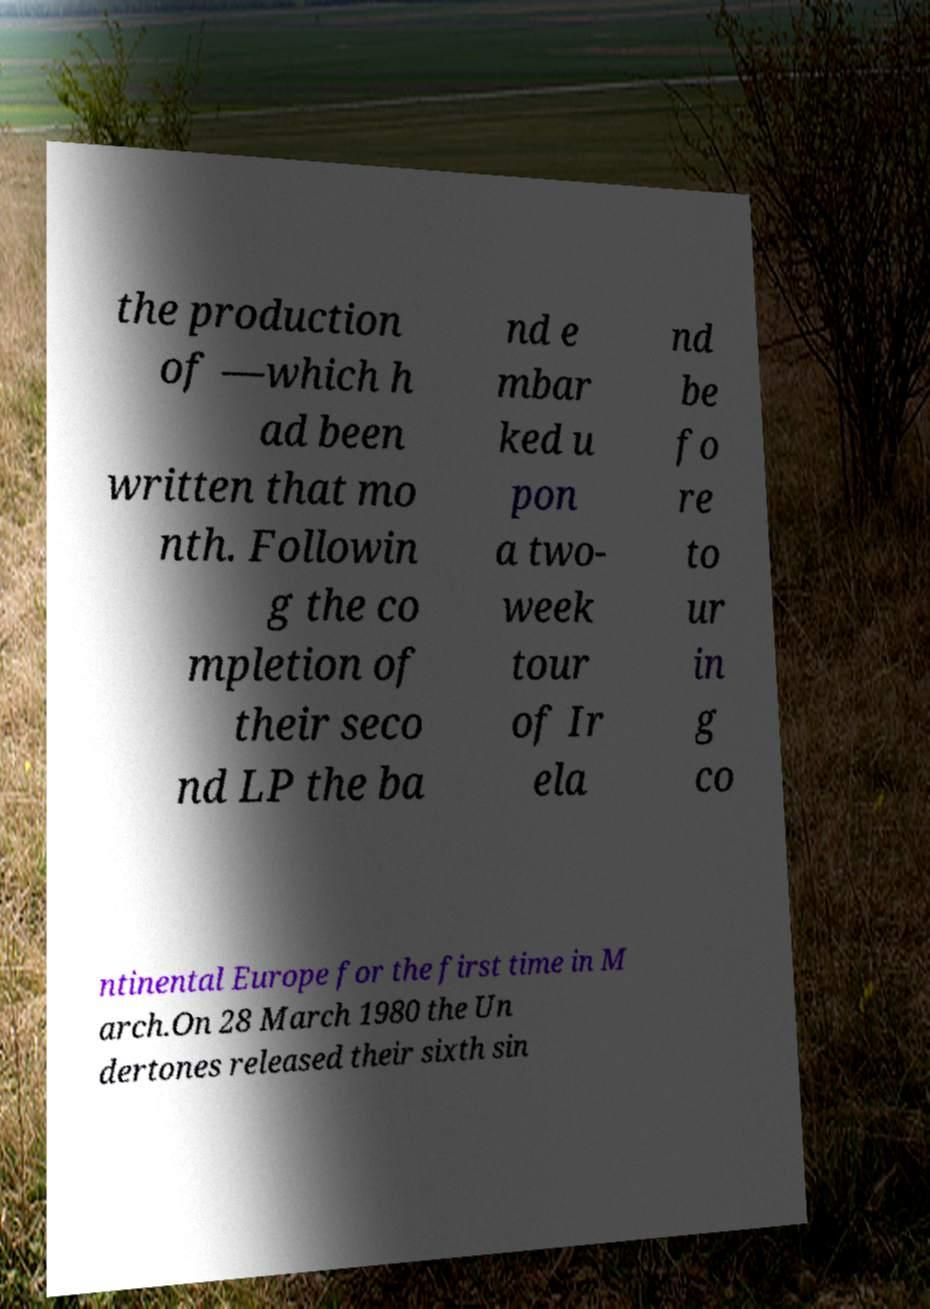Please identify and transcribe the text found in this image. the production of —which h ad been written that mo nth. Followin g the co mpletion of their seco nd LP the ba nd e mbar ked u pon a two- week tour of Ir ela nd be fo re to ur in g co ntinental Europe for the first time in M arch.On 28 March 1980 the Un dertones released their sixth sin 